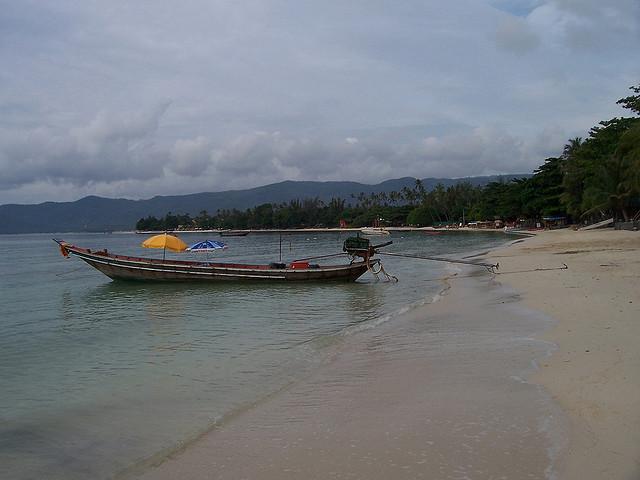Is the boat moving?
Short answer required. No. Is this boat powered by oars?
Write a very short answer. Yes. Is it a pleasant, sunny day?
Give a very brief answer. No. Are we looking at the front or the back of the boat?
Answer briefly. Side. Is the boat in a lake or beach?
Write a very short answer. Beach. What is reflecting?
Answer briefly. Boat. How many umbrellas are on the boat?
Keep it brief. 2. Is there a person in the boat?
Give a very brief answer. No. 